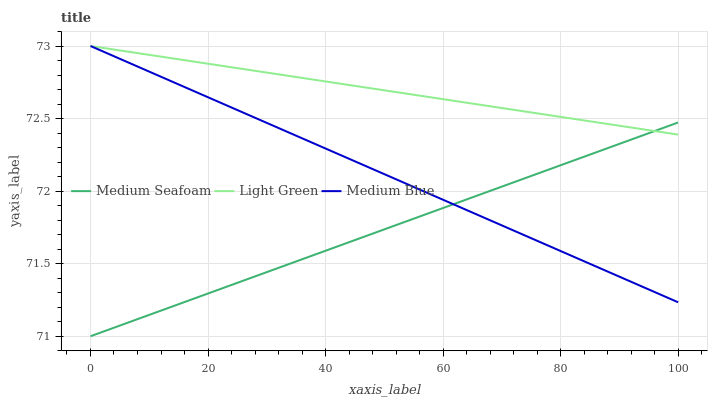Does Medium Seafoam have the minimum area under the curve?
Answer yes or no. Yes. Does Light Green have the maximum area under the curve?
Answer yes or no. Yes. Does Light Green have the minimum area under the curve?
Answer yes or no. No. Does Medium Seafoam have the maximum area under the curve?
Answer yes or no. No. Is Light Green the smoothest?
Answer yes or no. Yes. Is Medium Blue the roughest?
Answer yes or no. Yes. Is Medium Seafoam the smoothest?
Answer yes or no. No. Is Medium Seafoam the roughest?
Answer yes or no. No. Does Light Green have the lowest value?
Answer yes or no. No. Does Medium Seafoam have the highest value?
Answer yes or no. No. 